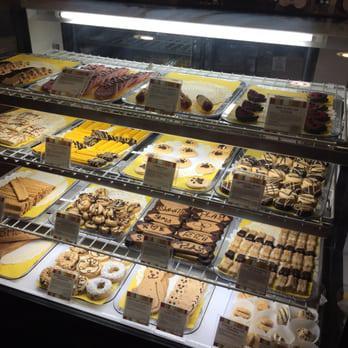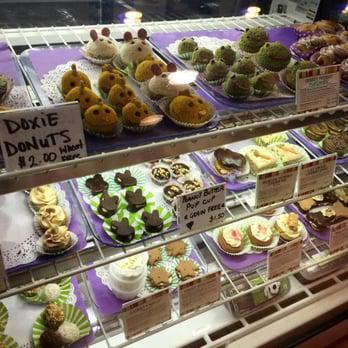The first image is the image on the left, the second image is the image on the right. For the images displayed, is the sentence "In one of the images, a dog is looking at the cakes." factually correct? Answer yes or no. No. The first image is the image on the left, the second image is the image on the right. Assess this claim about the two images: "A real dog is standing on all fours in front of a display case in one image.". Correct or not? Answer yes or no. No. 